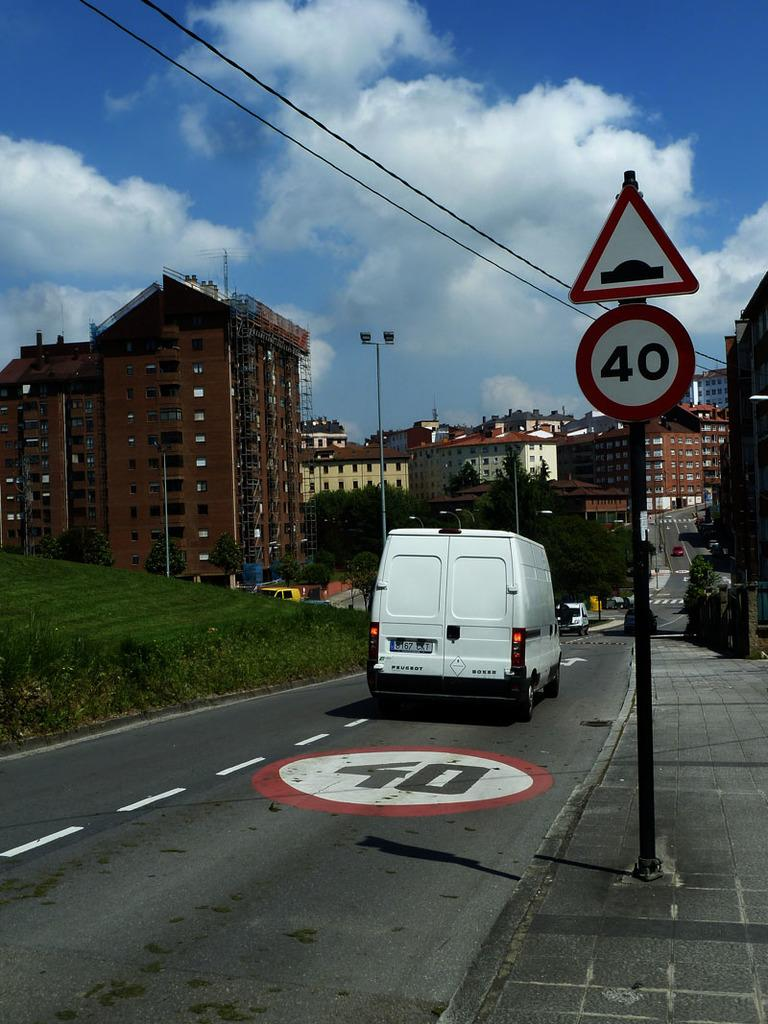What is happening on the road in the image? There are vehicles moving on the road in the image. What can be seen near the road in the image? There is a sign board in the image. What is visible in the background of the image? There are buildings, trees, poles, and the sky visible in the background of the image. What type of magic is being performed by the rock in the image? There is no rock performing magic in the image. 